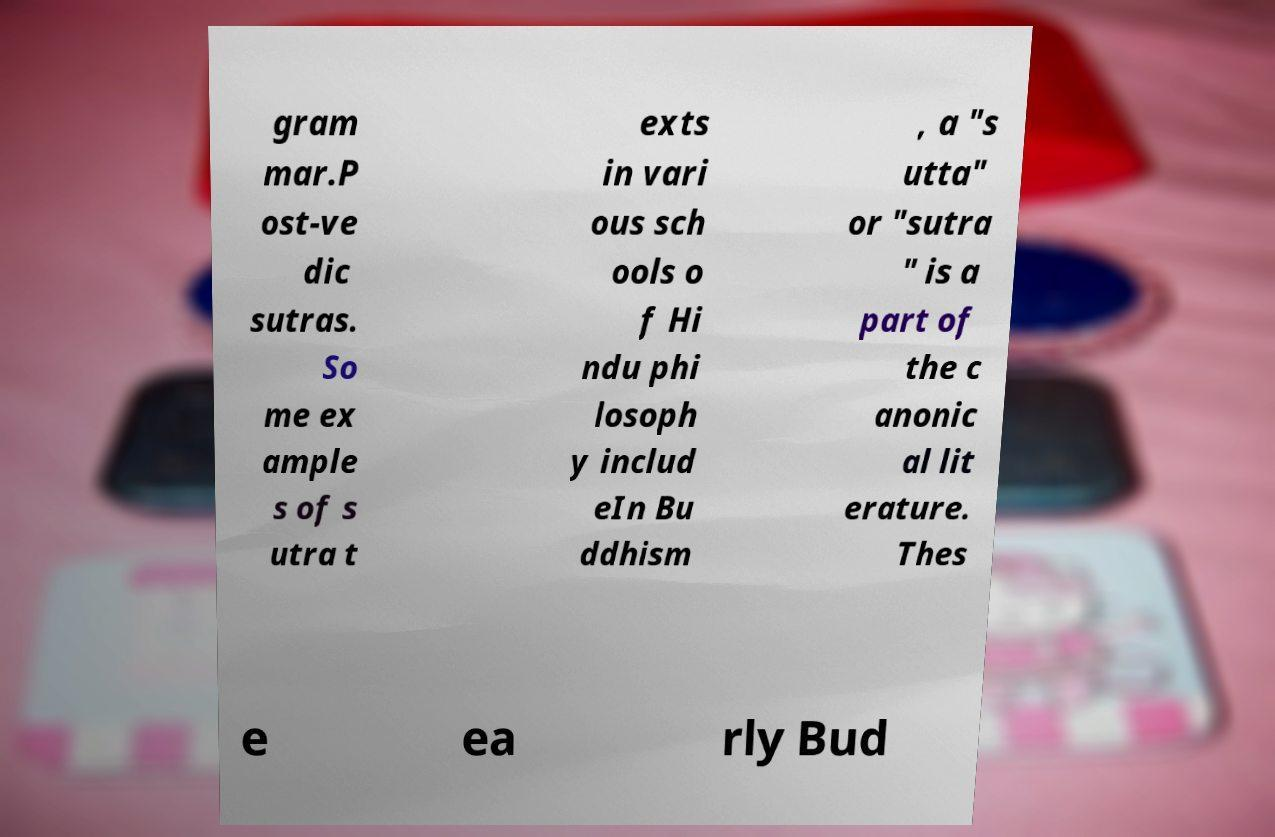I need the written content from this picture converted into text. Can you do that? gram mar.P ost-ve dic sutras. So me ex ample s of s utra t exts in vari ous sch ools o f Hi ndu phi losoph y includ eIn Bu ddhism , a "s utta" or "sutra " is a part of the c anonic al lit erature. Thes e ea rly Bud 